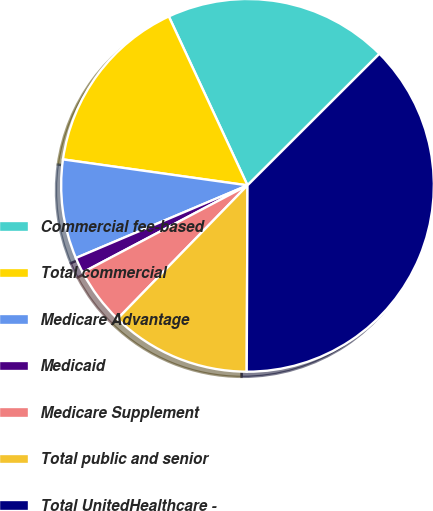<chart> <loc_0><loc_0><loc_500><loc_500><pie_chart><fcel>Commercial fee-based<fcel>Total commercial<fcel>Medicare Advantage<fcel>Medicaid<fcel>Medicare Supplement<fcel>Total public and senior<fcel>Total UnitedHealthcare -<nl><fcel>19.46%<fcel>15.84%<fcel>8.6%<fcel>1.36%<fcel>4.98%<fcel>12.22%<fcel>37.55%<nl></chart> 